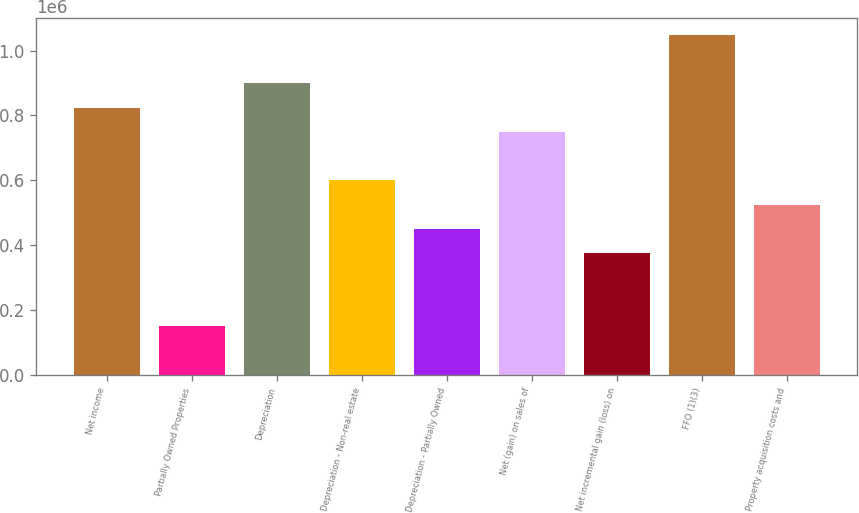Convert chart. <chart><loc_0><loc_0><loc_500><loc_500><bar_chart><fcel>Net income<fcel>Partially Owned Properties<fcel>Depreciation<fcel>Depreciation - Non-real estate<fcel>Depreciation - Partially Owned<fcel>Net (gain) on sales of<fcel>Net incremental gain (loss) on<fcel>FFO (1)(3)<fcel>Property acquisition costs and<nl><fcel>824428<fcel>150697<fcel>899287<fcel>599851<fcel>450133<fcel>749569<fcel>375274<fcel>1.049e+06<fcel>524992<nl></chart> 